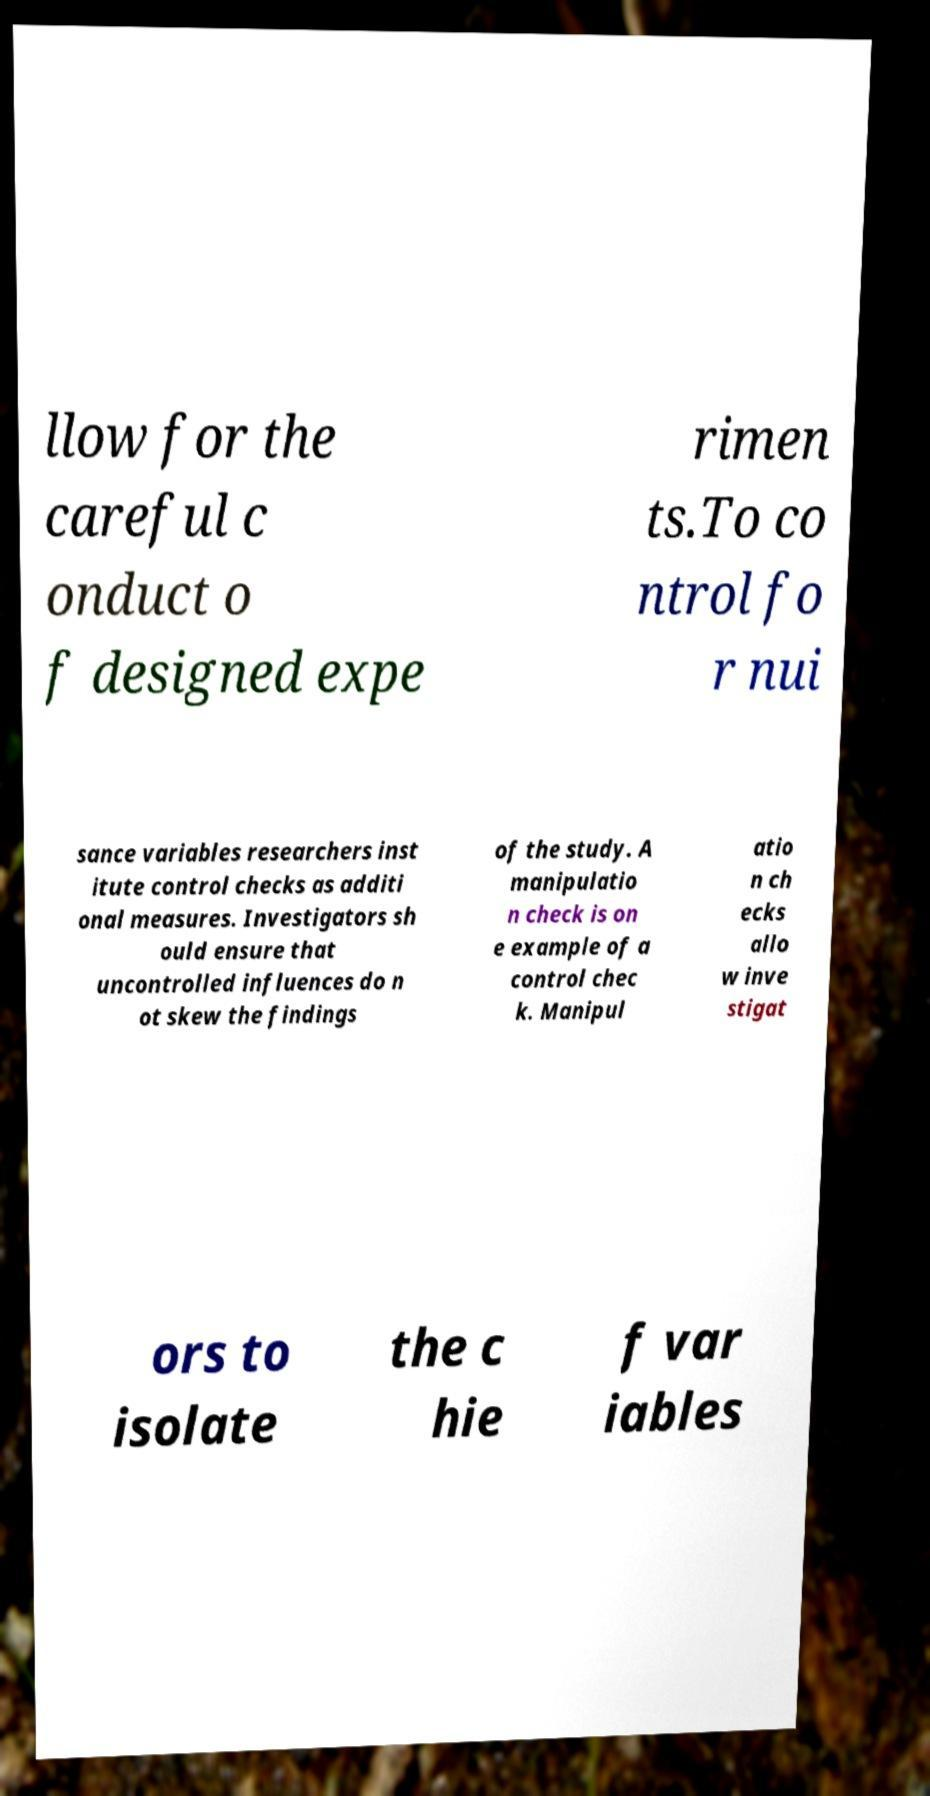Please read and relay the text visible in this image. What does it say? llow for the careful c onduct o f designed expe rimen ts.To co ntrol fo r nui sance variables researchers inst itute control checks as additi onal measures. Investigators sh ould ensure that uncontrolled influences do n ot skew the findings of the study. A manipulatio n check is on e example of a control chec k. Manipul atio n ch ecks allo w inve stigat ors to isolate the c hie f var iables 